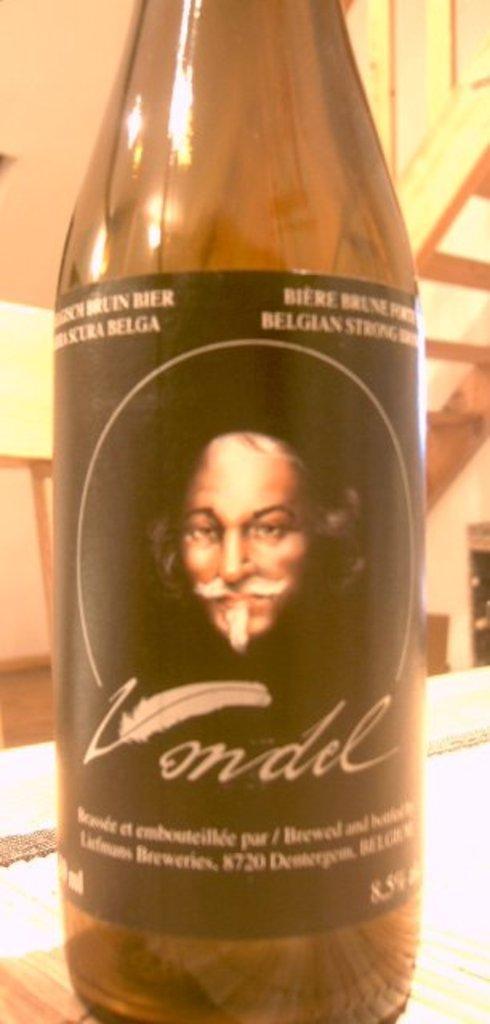Can you describe this image briefly? In this picture we can see a bottle with sticker to it and on sticker we can see feather, man and this is placed on a table and in background we can see wall, wooden steps. 